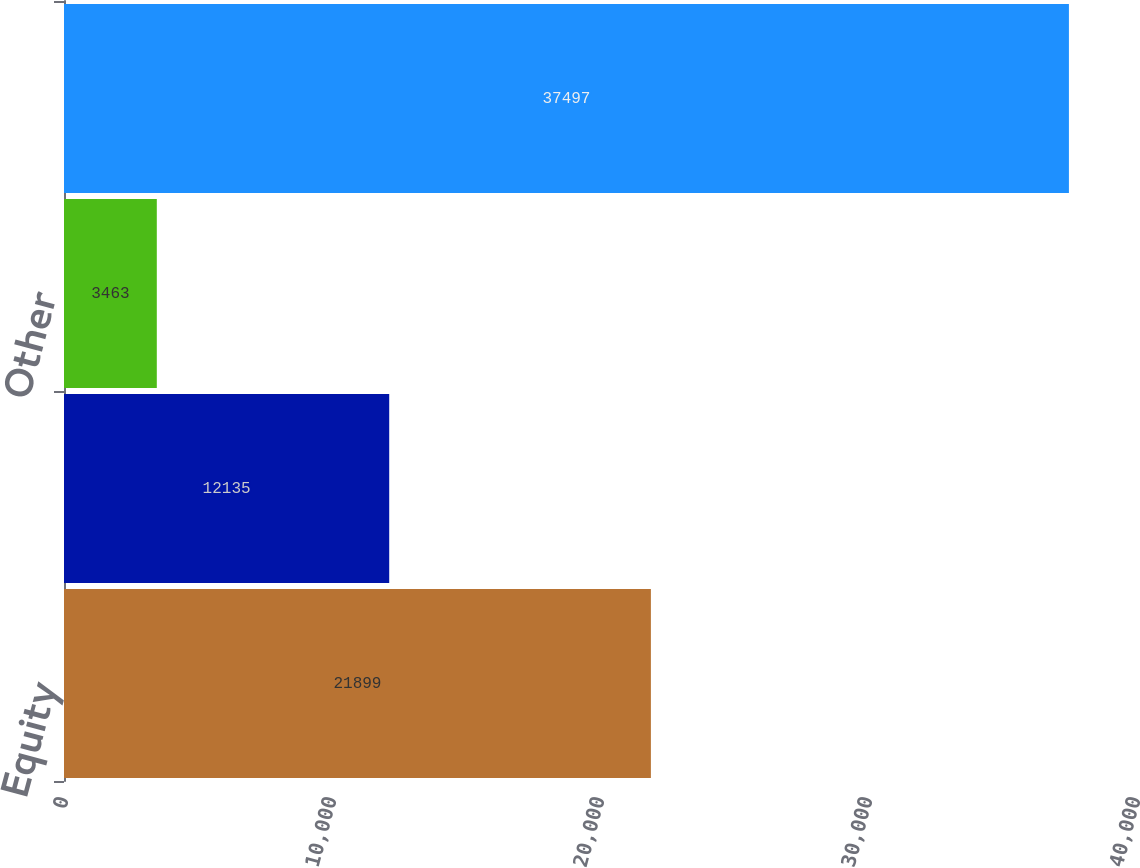Convert chart. <chart><loc_0><loc_0><loc_500><loc_500><bar_chart><fcel>Equity<fcel>Bond<fcel>Other<fcel>Total mutual funds<nl><fcel>21899<fcel>12135<fcel>3463<fcel>37497<nl></chart> 